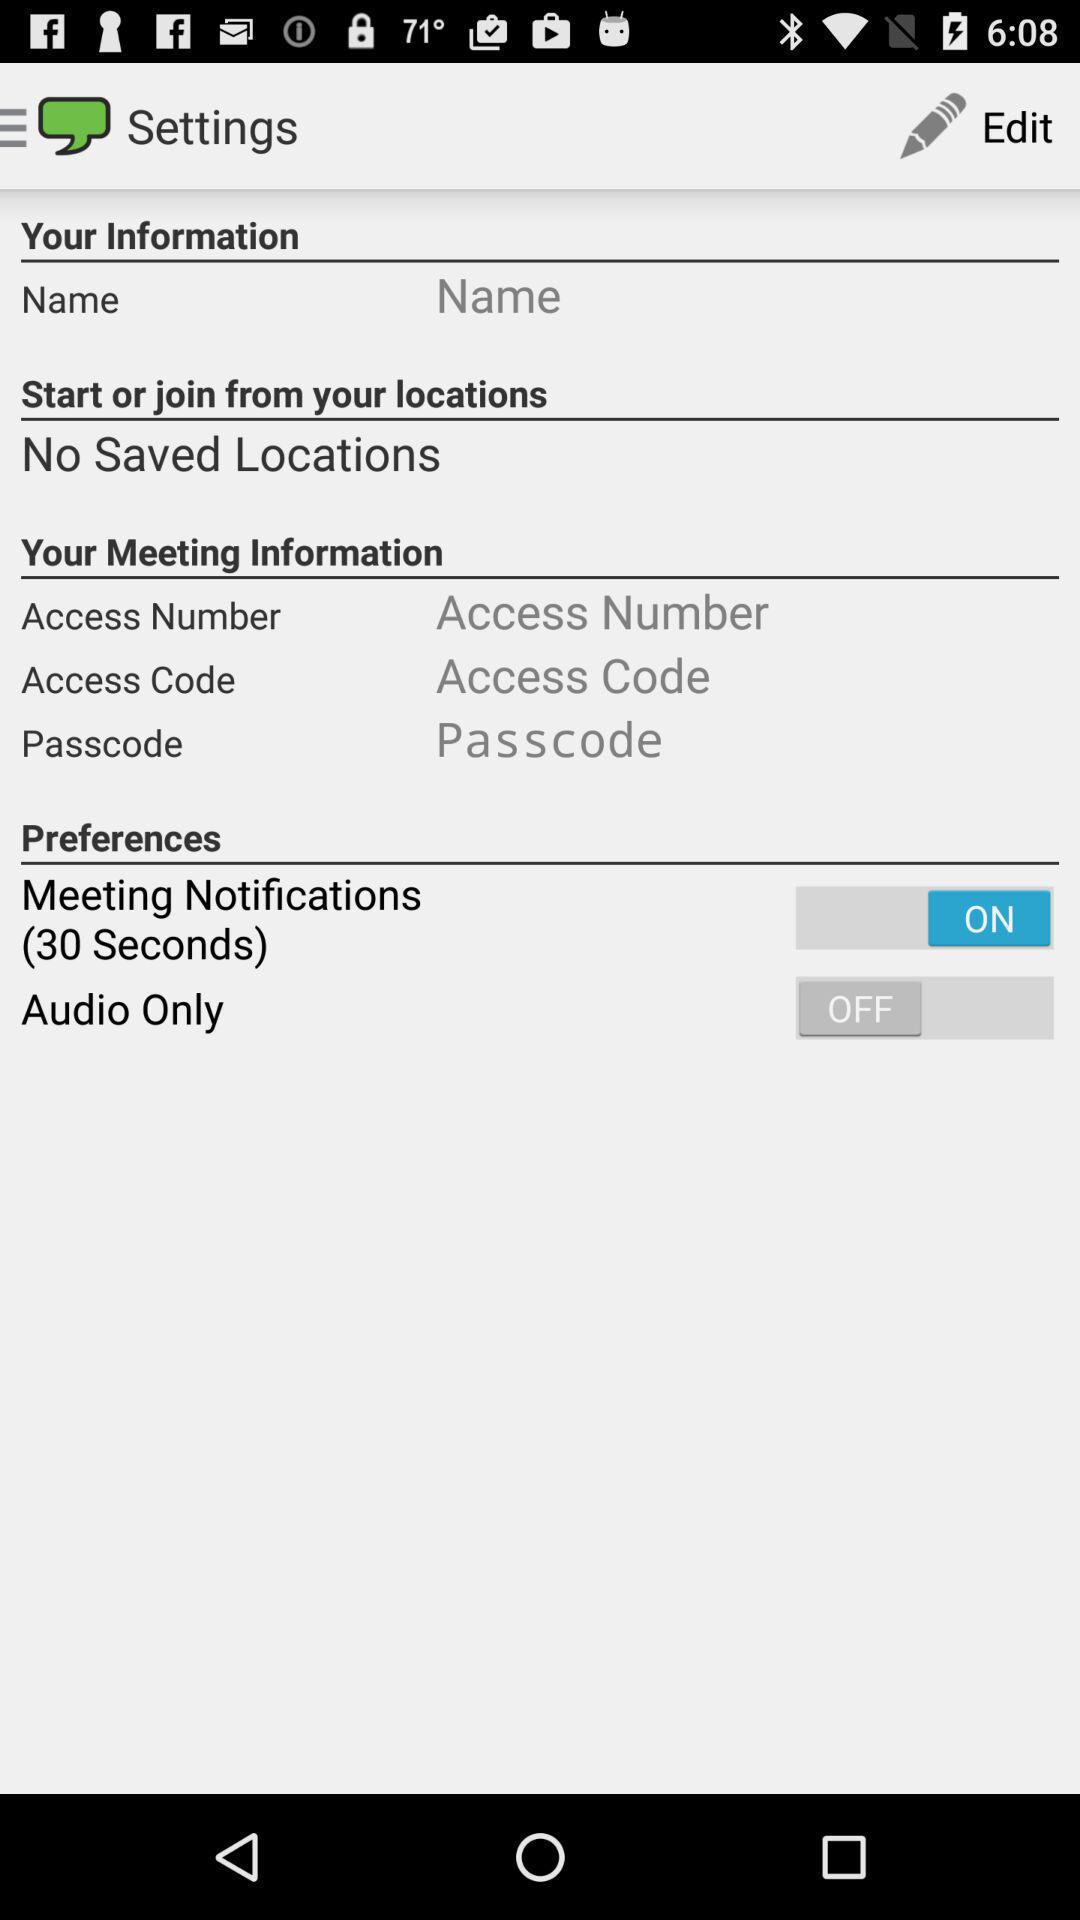What is the status of "Audio Only"? The status of "Audio Only" is "off". 